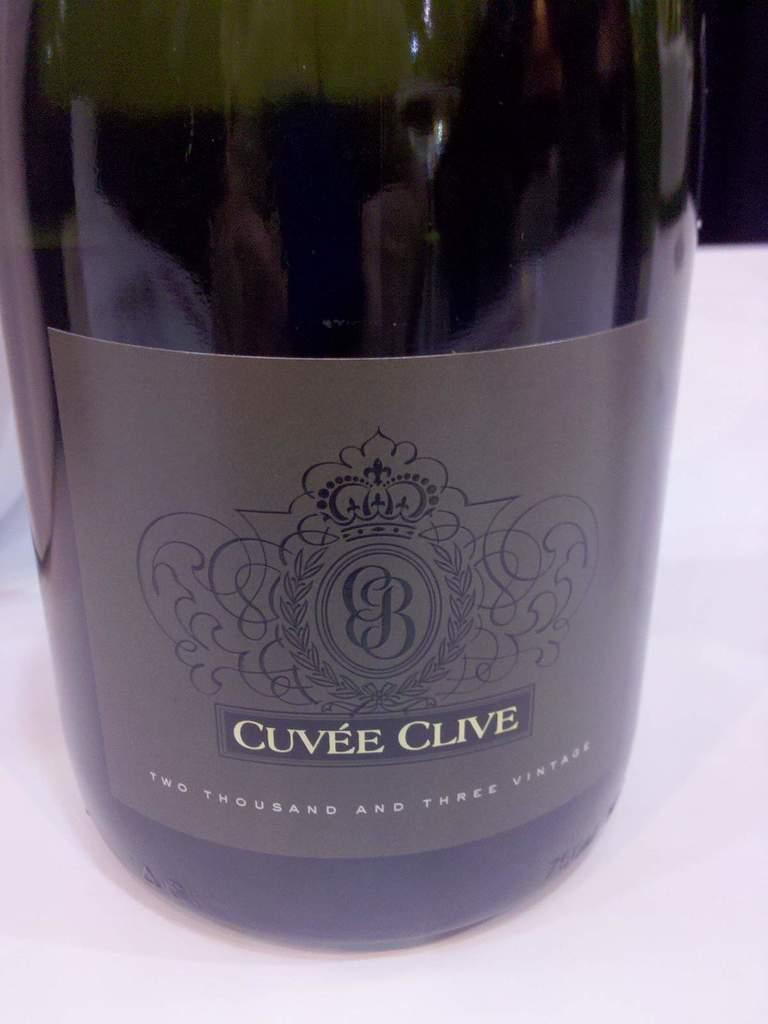What is present in the image that can hold a liquid? There is a bottle in the image that can hold a liquid. What is on the bottle in the image? The bottle has a sticker on it. What is the color of the object in the image? The object in the image is white. How would you describe the overall appearance of the image? The background of the image is dark. Can you tell me how many deer are visible in the image? There are no deer present in the image. What type of book is being read by the person in the image? There is no person or book present in the image. 